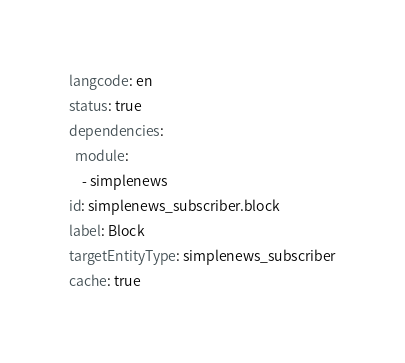<code> <loc_0><loc_0><loc_500><loc_500><_YAML_>langcode: en
status: true
dependencies:
  module:
    - simplenews
id: simplenews_subscriber.block
label: Block
targetEntityType: simplenews_subscriber
cache: true
</code> 